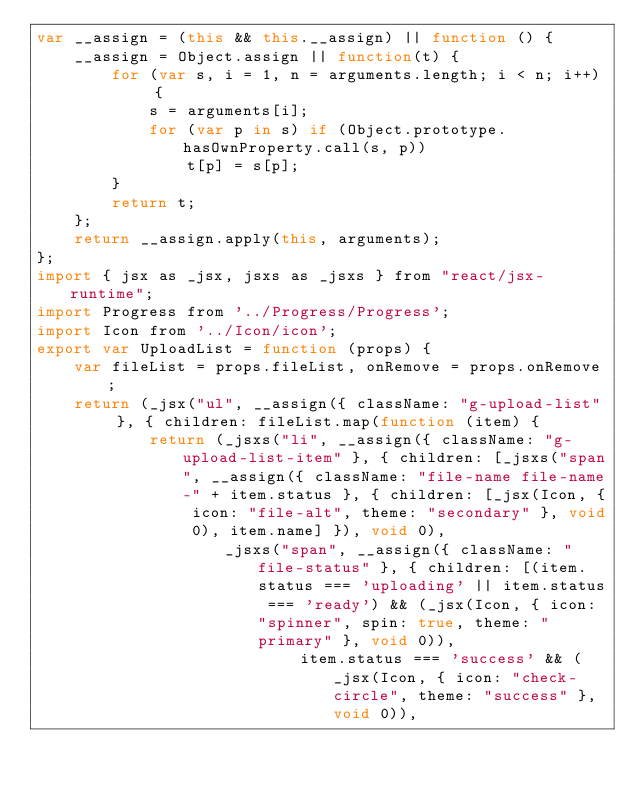Convert code to text. <code><loc_0><loc_0><loc_500><loc_500><_JavaScript_>var __assign = (this && this.__assign) || function () {
    __assign = Object.assign || function(t) {
        for (var s, i = 1, n = arguments.length; i < n; i++) {
            s = arguments[i];
            for (var p in s) if (Object.prototype.hasOwnProperty.call(s, p))
                t[p] = s[p];
        }
        return t;
    };
    return __assign.apply(this, arguments);
};
import { jsx as _jsx, jsxs as _jsxs } from "react/jsx-runtime";
import Progress from '../Progress/Progress';
import Icon from '../Icon/icon';
export var UploadList = function (props) {
    var fileList = props.fileList, onRemove = props.onRemove;
    return (_jsx("ul", __assign({ className: "g-upload-list" }, { children: fileList.map(function (item) {
            return (_jsxs("li", __assign({ className: "g-upload-list-item" }, { children: [_jsxs("span", __assign({ className: "file-name file-name-" + item.status }, { children: [_jsx(Icon, { icon: "file-alt", theme: "secondary" }, void 0), item.name] }), void 0),
                    _jsxs("span", __assign({ className: "file-status" }, { children: [(item.status === 'uploading' || item.status === 'ready') && (_jsx(Icon, { icon: "spinner", spin: true, theme: "primary" }, void 0)),
                            item.status === 'success' && (_jsx(Icon, { icon: "check-circle", theme: "success" }, void 0)),</code> 